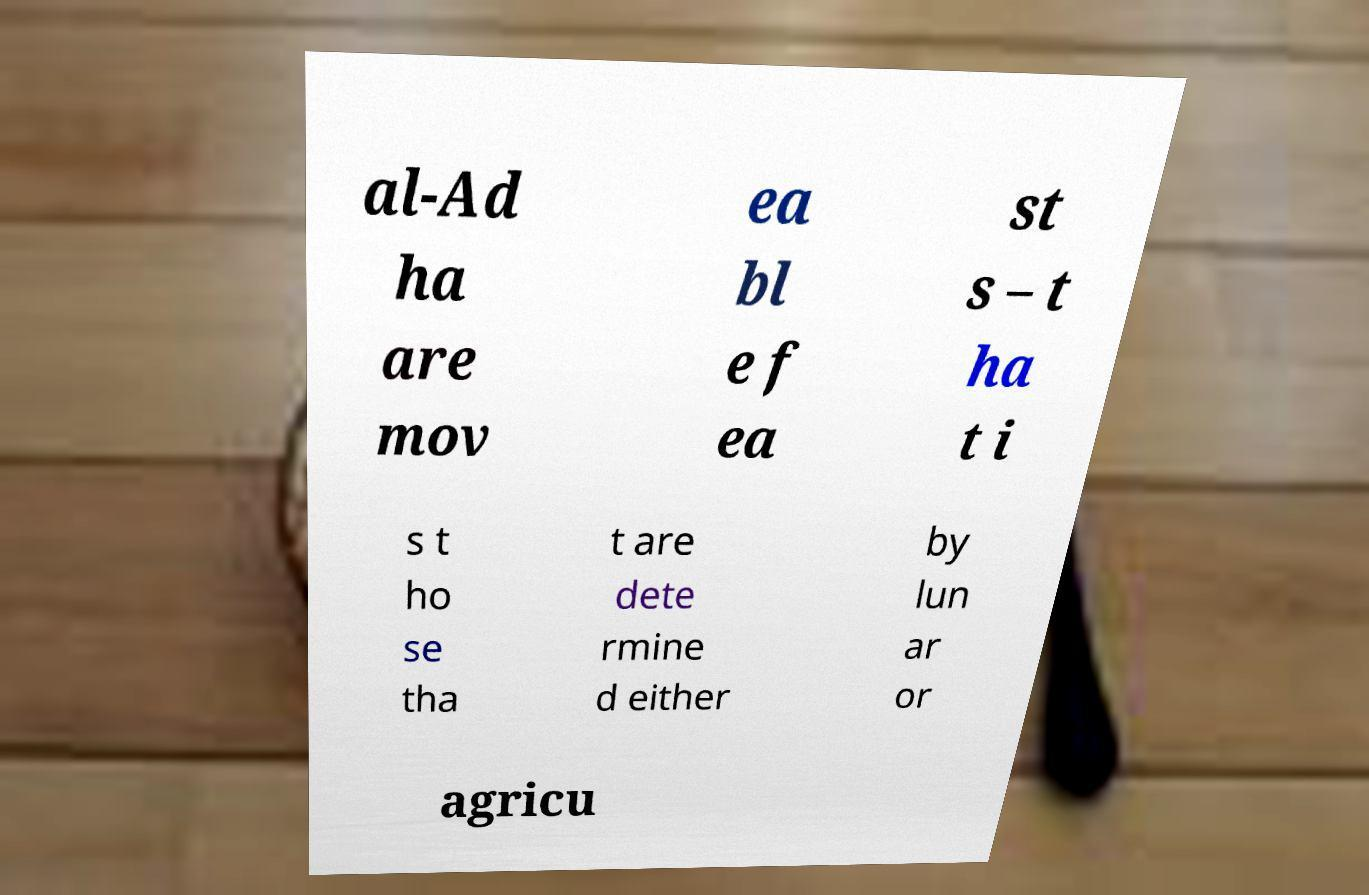I need the written content from this picture converted into text. Can you do that? al-Ad ha are mov ea bl e f ea st s – t ha t i s t ho se tha t are dete rmine d either by lun ar or agricu 